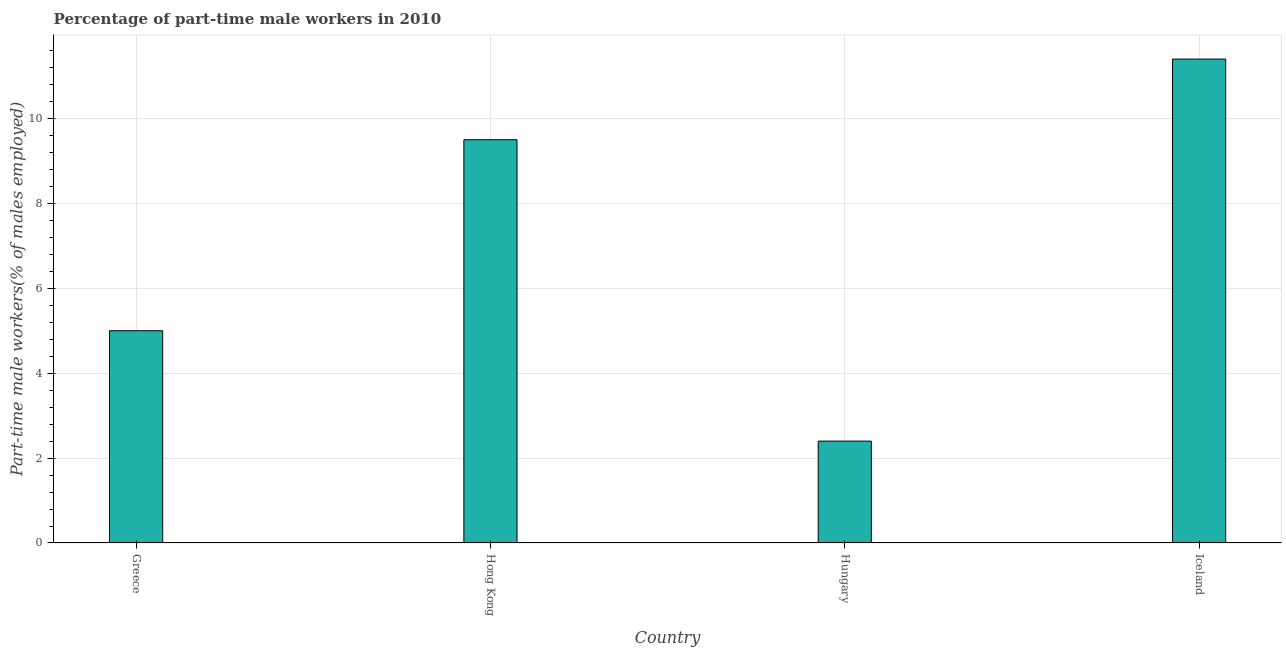What is the title of the graph?
Your answer should be very brief. Percentage of part-time male workers in 2010. What is the label or title of the X-axis?
Give a very brief answer. Country. What is the label or title of the Y-axis?
Offer a very short reply. Part-time male workers(% of males employed). Across all countries, what is the maximum percentage of part-time male workers?
Keep it short and to the point. 11.4. Across all countries, what is the minimum percentage of part-time male workers?
Offer a terse response. 2.4. In which country was the percentage of part-time male workers minimum?
Give a very brief answer. Hungary. What is the sum of the percentage of part-time male workers?
Give a very brief answer. 28.3. What is the average percentage of part-time male workers per country?
Provide a succinct answer. 7.08. What is the median percentage of part-time male workers?
Your answer should be compact. 7.25. In how many countries, is the percentage of part-time male workers greater than 11.2 %?
Your response must be concise. 1. What is the ratio of the percentage of part-time male workers in Hungary to that in Iceland?
Your response must be concise. 0.21. Is the difference between the percentage of part-time male workers in Greece and Hong Kong greater than the difference between any two countries?
Make the answer very short. No. What is the difference between the highest and the second highest percentage of part-time male workers?
Your answer should be compact. 1.9. Is the sum of the percentage of part-time male workers in Hungary and Iceland greater than the maximum percentage of part-time male workers across all countries?
Your answer should be compact. Yes. What is the difference between the highest and the lowest percentage of part-time male workers?
Make the answer very short. 9. Are all the bars in the graph horizontal?
Provide a succinct answer. No. Are the values on the major ticks of Y-axis written in scientific E-notation?
Provide a succinct answer. No. What is the Part-time male workers(% of males employed) of Hungary?
Offer a terse response. 2.4. What is the Part-time male workers(% of males employed) in Iceland?
Give a very brief answer. 11.4. What is the difference between the Part-time male workers(% of males employed) in Greece and Iceland?
Offer a very short reply. -6.4. What is the difference between the Part-time male workers(% of males employed) in Hong Kong and Iceland?
Your answer should be compact. -1.9. What is the ratio of the Part-time male workers(% of males employed) in Greece to that in Hong Kong?
Ensure brevity in your answer.  0.53. What is the ratio of the Part-time male workers(% of males employed) in Greece to that in Hungary?
Make the answer very short. 2.08. What is the ratio of the Part-time male workers(% of males employed) in Greece to that in Iceland?
Ensure brevity in your answer.  0.44. What is the ratio of the Part-time male workers(% of males employed) in Hong Kong to that in Hungary?
Keep it short and to the point. 3.96. What is the ratio of the Part-time male workers(% of males employed) in Hong Kong to that in Iceland?
Offer a terse response. 0.83. What is the ratio of the Part-time male workers(% of males employed) in Hungary to that in Iceland?
Your answer should be compact. 0.21. 